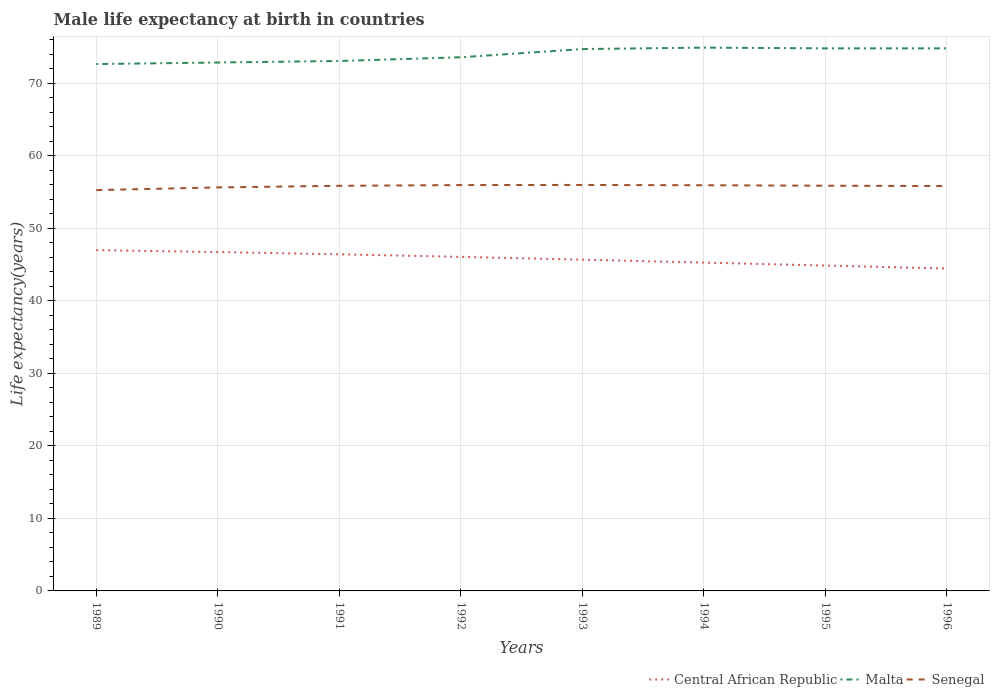Does the line corresponding to Malta intersect with the line corresponding to Senegal?
Your answer should be very brief. No. Across all years, what is the maximum male life expectancy at birth in Malta?
Your response must be concise. 72.63. What is the total male life expectancy at birth in Central African Republic in the graph?
Keep it short and to the point. 0.31. What is the difference between the highest and the second highest male life expectancy at birth in Malta?
Offer a terse response. 2.27. Is the male life expectancy at birth in Central African Republic strictly greater than the male life expectancy at birth in Senegal over the years?
Provide a succinct answer. Yes. How many years are there in the graph?
Ensure brevity in your answer.  8. What is the difference between two consecutive major ticks on the Y-axis?
Your answer should be very brief. 10. Are the values on the major ticks of Y-axis written in scientific E-notation?
Your response must be concise. No. Does the graph contain any zero values?
Ensure brevity in your answer.  No. How many legend labels are there?
Your answer should be compact. 3. How are the legend labels stacked?
Give a very brief answer. Horizontal. What is the title of the graph?
Ensure brevity in your answer.  Male life expectancy at birth in countries. What is the label or title of the X-axis?
Your answer should be compact. Years. What is the label or title of the Y-axis?
Your response must be concise. Life expectancy(years). What is the Life expectancy(years) in Central African Republic in 1989?
Make the answer very short. 46.98. What is the Life expectancy(years) of Malta in 1989?
Your response must be concise. 72.63. What is the Life expectancy(years) in Senegal in 1989?
Provide a succinct answer. 55.26. What is the Life expectancy(years) of Central African Republic in 1990?
Provide a short and direct response. 46.72. What is the Life expectancy(years) of Malta in 1990?
Ensure brevity in your answer.  72.85. What is the Life expectancy(years) of Senegal in 1990?
Keep it short and to the point. 55.63. What is the Life expectancy(years) in Central African Republic in 1991?
Your response must be concise. 46.41. What is the Life expectancy(years) in Malta in 1991?
Provide a short and direct response. 73.06. What is the Life expectancy(years) of Senegal in 1991?
Give a very brief answer. 55.85. What is the Life expectancy(years) of Central African Republic in 1992?
Your answer should be very brief. 46.05. What is the Life expectancy(years) in Malta in 1992?
Keep it short and to the point. 73.57. What is the Life expectancy(years) of Senegal in 1992?
Your response must be concise. 55.95. What is the Life expectancy(years) of Central African Republic in 1993?
Give a very brief answer. 45.67. What is the Life expectancy(years) in Malta in 1993?
Provide a short and direct response. 74.7. What is the Life expectancy(years) of Senegal in 1993?
Provide a short and direct response. 55.97. What is the Life expectancy(years) of Central African Republic in 1994?
Ensure brevity in your answer.  45.27. What is the Life expectancy(years) in Malta in 1994?
Ensure brevity in your answer.  74.9. What is the Life expectancy(years) in Senegal in 1994?
Give a very brief answer. 55.93. What is the Life expectancy(years) of Central African Republic in 1995?
Your answer should be very brief. 44.86. What is the Life expectancy(years) of Malta in 1995?
Give a very brief answer. 74.8. What is the Life expectancy(years) in Senegal in 1995?
Provide a succinct answer. 55.86. What is the Life expectancy(years) in Central African Republic in 1996?
Offer a very short reply. 44.45. What is the Life expectancy(years) of Malta in 1996?
Offer a terse response. 74.8. What is the Life expectancy(years) of Senegal in 1996?
Offer a terse response. 55.81. Across all years, what is the maximum Life expectancy(years) of Central African Republic?
Give a very brief answer. 46.98. Across all years, what is the maximum Life expectancy(years) of Malta?
Provide a succinct answer. 74.9. Across all years, what is the maximum Life expectancy(years) of Senegal?
Make the answer very short. 55.97. Across all years, what is the minimum Life expectancy(years) in Central African Republic?
Make the answer very short. 44.45. Across all years, what is the minimum Life expectancy(years) in Malta?
Offer a terse response. 72.63. Across all years, what is the minimum Life expectancy(years) in Senegal?
Your answer should be very brief. 55.26. What is the total Life expectancy(years) of Central African Republic in the graph?
Your response must be concise. 366.4. What is the total Life expectancy(years) in Malta in the graph?
Offer a terse response. 591.31. What is the total Life expectancy(years) of Senegal in the graph?
Provide a short and direct response. 446.25. What is the difference between the Life expectancy(years) in Central African Republic in 1989 and that in 1990?
Your answer should be compact. 0.26. What is the difference between the Life expectancy(years) of Malta in 1989 and that in 1990?
Provide a short and direct response. -0.21. What is the difference between the Life expectancy(years) in Senegal in 1989 and that in 1990?
Offer a very short reply. -0.37. What is the difference between the Life expectancy(years) of Central African Republic in 1989 and that in 1991?
Ensure brevity in your answer.  0.58. What is the difference between the Life expectancy(years) of Malta in 1989 and that in 1991?
Offer a very short reply. -0.42. What is the difference between the Life expectancy(years) in Senegal in 1989 and that in 1991?
Your response must be concise. -0.59. What is the difference between the Life expectancy(years) in Central African Republic in 1989 and that in 1992?
Your response must be concise. 0.93. What is the difference between the Life expectancy(years) in Malta in 1989 and that in 1992?
Provide a succinct answer. -0.94. What is the difference between the Life expectancy(years) of Senegal in 1989 and that in 1992?
Ensure brevity in your answer.  -0.69. What is the difference between the Life expectancy(years) in Central African Republic in 1989 and that in 1993?
Your response must be concise. 1.32. What is the difference between the Life expectancy(years) of Malta in 1989 and that in 1993?
Keep it short and to the point. -2.07. What is the difference between the Life expectancy(years) of Senegal in 1989 and that in 1993?
Make the answer very short. -0.71. What is the difference between the Life expectancy(years) of Central African Republic in 1989 and that in 1994?
Your answer should be very brief. 1.72. What is the difference between the Life expectancy(years) in Malta in 1989 and that in 1994?
Provide a succinct answer. -2.27. What is the difference between the Life expectancy(years) in Senegal in 1989 and that in 1994?
Keep it short and to the point. -0.67. What is the difference between the Life expectancy(years) in Central African Republic in 1989 and that in 1995?
Keep it short and to the point. 2.13. What is the difference between the Life expectancy(years) of Malta in 1989 and that in 1995?
Keep it short and to the point. -2.17. What is the difference between the Life expectancy(years) of Senegal in 1989 and that in 1995?
Your response must be concise. -0.61. What is the difference between the Life expectancy(years) of Central African Republic in 1989 and that in 1996?
Ensure brevity in your answer.  2.54. What is the difference between the Life expectancy(years) of Malta in 1989 and that in 1996?
Offer a very short reply. -2.17. What is the difference between the Life expectancy(years) of Senegal in 1989 and that in 1996?
Offer a very short reply. -0.56. What is the difference between the Life expectancy(years) of Central African Republic in 1990 and that in 1991?
Your response must be concise. 0.31. What is the difference between the Life expectancy(years) of Malta in 1990 and that in 1991?
Your response must be concise. -0.21. What is the difference between the Life expectancy(years) of Senegal in 1990 and that in 1991?
Your answer should be very brief. -0.22. What is the difference between the Life expectancy(years) of Central African Republic in 1990 and that in 1992?
Make the answer very short. 0.67. What is the difference between the Life expectancy(years) of Malta in 1990 and that in 1992?
Give a very brief answer. -0.72. What is the difference between the Life expectancy(years) in Senegal in 1990 and that in 1992?
Your response must be concise. -0.32. What is the difference between the Life expectancy(years) of Central African Republic in 1990 and that in 1993?
Provide a succinct answer. 1.05. What is the difference between the Life expectancy(years) of Malta in 1990 and that in 1993?
Your response must be concise. -1.85. What is the difference between the Life expectancy(years) in Senegal in 1990 and that in 1993?
Make the answer very short. -0.34. What is the difference between the Life expectancy(years) of Central African Republic in 1990 and that in 1994?
Make the answer very short. 1.46. What is the difference between the Life expectancy(years) in Malta in 1990 and that in 1994?
Make the answer very short. -2.05. What is the difference between the Life expectancy(years) in Senegal in 1990 and that in 1994?
Make the answer very short. -0.3. What is the difference between the Life expectancy(years) of Central African Republic in 1990 and that in 1995?
Your response must be concise. 1.86. What is the difference between the Life expectancy(years) in Malta in 1990 and that in 1995?
Keep it short and to the point. -1.95. What is the difference between the Life expectancy(years) of Senegal in 1990 and that in 1995?
Offer a terse response. -0.24. What is the difference between the Life expectancy(years) of Central African Republic in 1990 and that in 1996?
Offer a very short reply. 2.27. What is the difference between the Life expectancy(years) in Malta in 1990 and that in 1996?
Your response must be concise. -1.95. What is the difference between the Life expectancy(years) of Senegal in 1990 and that in 1996?
Provide a succinct answer. -0.19. What is the difference between the Life expectancy(years) in Central African Republic in 1991 and that in 1992?
Give a very brief answer. 0.35. What is the difference between the Life expectancy(years) of Malta in 1991 and that in 1992?
Your answer should be compact. -0.51. What is the difference between the Life expectancy(years) in Senegal in 1991 and that in 1992?
Ensure brevity in your answer.  -0.1. What is the difference between the Life expectancy(years) in Central African Republic in 1991 and that in 1993?
Provide a succinct answer. 0.74. What is the difference between the Life expectancy(years) of Malta in 1991 and that in 1993?
Make the answer very short. -1.64. What is the difference between the Life expectancy(years) of Senegal in 1991 and that in 1993?
Make the answer very short. -0.12. What is the difference between the Life expectancy(years) in Central African Republic in 1991 and that in 1994?
Provide a succinct answer. 1.14. What is the difference between the Life expectancy(years) in Malta in 1991 and that in 1994?
Your answer should be compact. -1.84. What is the difference between the Life expectancy(years) in Senegal in 1991 and that in 1994?
Give a very brief answer. -0.08. What is the difference between the Life expectancy(years) in Central African Republic in 1991 and that in 1995?
Ensure brevity in your answer.  1.55. What is the difference between the Life expectancy(years) in Malta in 1991 and that in 1995?
Offer a terse response. -1.74. What is the difference between the Life expectancy(years) of Senegal in 1991 and that in 1995?
Your answer should be very brief. -0.01. What is the difference between the Life expectancy(years) in Central African Republic in 1991 and that in 1996?
Provide a short and direct response. 1.96. What is the difference between the Life expectancy(years) in Malta in 1991 and that in 1996?
Provide a short and direct response. -1.74. What is the difference between the Life expectancy(years) in Senegal in 1991 and that in 1996?
Ensure brevity in your answer.  0.04. What is the difference between the Life expectancy(years) of Central African Republic in 1992 and that in 1993?
Offer a very short reply. 0.39. What is the difference between the Life expectancy(years) of Malta in 1992 and that in 1993?
Provide a succinct answer. -1.13. What is the difference between the Life expectancy(years) in Senegal in 1992 and that in 1993?
Your answer should be compact. -0.01. What is the difference between the Life expectancy(years) of Central African Republic in 1992 and that in 1994?
Keep it short and to the point. 0.79. What is the difference between the Life expectancy(years) in Malta in 1992 and that in 1994?
Ensure brevity in your answer.  -1.33. What is the difference between the Life expectancy(years) of Senegal in 1992 and that in 1994?
Your answer should be compact. 0.03. What is the difference between the Life expectancy(years) of Central African Republic in 1992 and that in 1995?
Your answer should be very brief. 1.2. What is the difference between the Life expectancy(years) of Malta in 1992 and that in 1995?
Make the answer very short. -1.23. What is the difference between the Life expectancy(years) in Senegal in 1992 and that in 1995?
Provide a short and direct response. 0.09. What is the difference between the Life expectancy(years) in Central African Republic in 1992 and that in 1996?
Give a very brief answer. 1.61. What is the difference between the Life expectancy(years) of Malta in 1992 and that in 1996?
Your answer should be compact. -1.23. What is the difference between the Life expectancy(years) in Senegal in 1992 and that in 1996?
Your answer should be very brief. 0.14. What is the difference between the Life expectancy(years) in Central African Republic in 1993 and that in 1994?
Your answer should be compact. 0.4. What is the difference between the Life expectancy(years) in Central African Republic in 1993 and that in 1995?
Offer a terse response. 0.81. What is the difference between the Life expectancy(years) in Senegal in 1993 and that in 1995?
Make the answer very short. 0.1. What is the difference between the Life expectancy(years) in Central African Republic in 1993 and that in 1996?
Provide a short and direct response. 1.22. What is the difference between the Life expectancy(years) of Senegal in 1993 and that in 1996?
Your answer should be very brief. 0.15. What is the difference between the Life expectancy(years) of Central African Republic in 1994 and that in 1995?
Offer a very short reply. 0.41. What is the difference between the Life expectancy(years) of Malta in 1994 and that in 1995?
Provide a succinct answer. 0.1. What is the difference between the Life expectancy(years) of Senegal in 1994 and that in 1995?
Offer a terse response. 0.06. What is the difference between the Life expectancy(years) of Central African Republic in 1994 and that in 1996?
Give a very brief answer. 0.82. What is the difference between the Life expectancy(years) in Senegal in 1994 and that in 1996?
Offer a very short reply. 0.11. What is the difference between the Life expectancy(years) in Central African Republic in 1995 and that in 1996?
Ensure brevity in your answer.  0.41. What is the difference between the Life expectancy(years) in Senegal in 1995 and that in 1996?
Your answer should be very brief. 0.05. What is the difference between the Life expectancy(years) of Central African Republic in 1989 and the Life expectancy(years) of Malta in 1990?
Provide a short and direct response. -25.86. What is the difference between the Life expectancy(years) in Central African Republic in 1989 and the Life expectancy(years) in Senegal in 1990?
Offer a very short reply. -8.64. What is the difference between the Life expectancy(years) in Malta in 1989 and the Life expectancy(years) in Senegal in 1990?
Provide a succinct answer. 17.01. What is the difference between the Life expectancy(years) in Central African Republic in 1989 and the Life expectancy(years) in Malta in 1991?
Give a very brief answer. -26.07. What is the difference between the Life expectancy(years) in Central African Republic in 1989 and the Life expectancy(years) in Senegal in 1991?
Your response must be concise. -8.87. What is the difference between the Life expectancy(years) of Malta in 1989 and the Life expectancy(years) of Senegal in 1991?
Offer a terse response. 16.79. What is the difference between the Life expectancy(years) of Central African Republic in 1989 and the Life expectancy(years) of Malta in 1992?
Provide a succinct answer. -26.59. What is the difference between the Life expectancy(years) of Central African Republic in 1989 and the Life expectancy(years) of Senegal in 1992?
Your response must be concise. -8.97. What is the difference between the Life expectancy(years) of Malta in 1989 and the Life expectancy(years) of Senegal in 1992?
Provide a short and direct response. 16.68. What is the difference between the Life expectancy(years) in Central African Republic in 1989 and the Life expectancy(years) in Malta in 1993?
Ensure brevity in your answer.  -27.72. What is the difference between the Life expectancy(years) of Central African Republic in 1989 and the Life expectancy(years) of Senegal in 1993?
Make the answer very short. -8.98. What is the difference between the Life expectancy(years) in Malta in 1989 and the Life expectancy(years) in Senegal in 1993?
Offer a very short reply. 16.67. What is the difference between the Life expectancy(years) in Central African Republic in 1989 and the Life expectancy(years) in Malta in 1994?
Your answer should be very brief. -27.92. What is the difference between the Life expectancy(years) in Central African Republic in 1989 and the Life expectancy(years) in Senegal in 1994?
Provide a short and direct response. -8.94. What is the difference between the Life expectancy(years) of Malta in 1989 and the Life expectancy(years) of Senegal in 1994?
Give a very brief answer. 16.71. What is the difference between the Life expectancy(years) of Central African Republic in 1989 and the Life expectancy(years) of Malta in 1995?
Your answer should be compact. -27.82. What is the difference between the Life expectancy(years) of Central African Republic in 1989 and the Life expectancy(years) of Senegal in 1995?
Offer a very short reply. -8.88. What is the difference between the Life expectancy(years) in Malta in 1989 and the Life expectancy(years) in Senegal in 1995?
Offer a very short reply. 16.77. What is the difference between the Life expectancy(years) of Central African Republic in 1989 and the Life expectancy(years) of Malta in 1996?
Give a very brief answer. -27.82. What is the difference between the Life expectancy(years) in Central African Republic in 1989 and the Life expectancy(years) in Senegal in 1996?
Make the answer very short. -8.83. What is the difference between the Life expectancy(years) of Malta in 1989 and the Life expectancy(years) of Senegal in 1996?
Ensure brevity in your answer.  16.82. What is the difference between the Life expectancy(years) in Central African Republic in 1990 and the Life expectancy(years) in Malta in 1991?
Ensure brevity in your answer.  -26.34. What is the difference between the Life expectancy(years) of Central African Republic in 1990 and the Life expectancy(years) of Senegal in 1991?
Provide a short and direct response. -9.13. What is the difference between the Life expectancy(years) in Malta in 1990 and the Life expectancy(years) in Senegal in 1991?
Provide a succinct answer. 17. What is the difference between the Life expectancy(years) in Central African Republic in 1990 and the Life expectancy(years) in Malta in 1992?
Offer a terse response. -26.85. What is the difference between the Life expectancy(years) in Central African Republic in 1990 and the Life expectancy(years) in Senegal in 1992?
Your response must be concise. -9.23. What is the difference between the Life expectancy(years) of Malta in 1990 and the Life expectancy(years) of Senegal in 1992?
Make the answer very short. 16.9. What is the difference between the Life expectancy(years) of Central African Republic in 1990 and the Life expectancy(years) of Malta in 1993?
Make the answer very short. -27.98. What is the difference between the Life expectancy(years) in Central African Republic in 1990 and the Life expectancy(years) in Senegal in 1993?
Your answer should be compact. -9.25. What is the difference between the Life expectancy(years) of Malta in 1990 and the Life expectancy(years) of Senegal in 1993?
Your answer should be very brief. 16.88. What is the difference between the Life expectancy(years) in Central African Republic in 1990 and the Life expectancy(years) in Malta in 1994?
Your answer should be very brief. -28.18. What is the difference between the Life expectancy(years) in Central African Republic in 1990 and the Life expectancy(years) in Senegal in 1994?
Provide a short and direct response. -9.21. What is the difference between the Life expectancy(years) of Malta in 1990 and the Life expectancy(years) of Senegal in 1994?
Give a very brief answer. 16.92. What is the difference between the Life expectancy(years) in Central African Republic in 1990 and the Life expectancy(years) in Malta in 1995?
Your answer should be compact. -28.08. What is the difference between the Life expectancy(years) of Central African Republic in 1990 and the Life expectancy(years) of Senegal in 1995?
Give a very brief answer. -9.14. What is the difference between the Life expectancy(years) in Malta in 1990 and the Life expectancy(years) in Senegal in 1995?
Your answer should be very brief. 16.98. What is the difference between the Life expectancy(years) of Central African Republic in 1990 and the Life expectancy(years) of Malta in 1996?
Offer a terse response. -28.08. What is the difference between the Life expectancy(years) in Central African Republic in 1990 and the Life expectancy(years) in Senegal in 1996?
Your answer should be very brief. -9.09. What is the difference between the Life expectancy(years) in Malta in 1990 and the Life expectancy(years) in Senegal in 1996?
Your answer should be compact. 17.03. What is the difference between the Life expectancy(years) in Central African Republic in 1991 and the Life expectancy(years) in Malta in 1992?
Provide a succinct answer. -27.16. What is the difference between the Life expectancy(years) of Central African Republic in 1991 and the Life expectancy(years) of Senegal in 1992?
Give a very brief answer. -9.54. What is the difference between the Life expectancy(years) of Malta in 1991 and the Life expectancy(years) of Senegal in 1992?
Provide a short and direct response. 17.11. What is the difference between the Life expectancy(years) of Central African Republic in 1991 and the Life expectancy(years) of Malta in 1993?
Make the answer very short. -28.29. What is the difference between the Life expectancy(years) in Central African Republic in 1991 and the Life expectancy(years) in Senegal in 1993?
Your answer should be very brief. -9.56. What is the difference between the Life expectancy(years) of Malta in 1991 and the Life expectancy(years) of Senegal in 1993?
Make the answer very short. 17.09. What is the difference between the Life expectancy(years) in Central African Republic in 1991 and the Life expectancy(years) in Malta in 1994?
Provide a succinct answer. -28.49. What is the difference between the Life expectancy(years) in Central African Republic in 1991 and the Life expectancy(years) in Senegal in 1994?
Your response must be concise. -9.52. What is the difference between the Life expectancy(years) in Malta in 1991 and the Life expectancy(years) in Senegal in 1994?
Offer a very short reply. 17.13. What is the difference between the Life expectancy(years) in Central African Republic in 1991 and the Life expectancy(years) in Malta in 1995?
Provide a succinct answer. -28.39. What is the difference between the Life expectancy(years) in Central African Republic in 1991 and the Life expectancy(years) in Senegal in 1995?
Your answer should be very brief. -9.46. What is the difference between the Life expectancy(years) of Malta in 1991 and the Life expectancy(years) of Senegal in 1995?
Keep it short and to the point. 17.19. What is the difference between the Life expectancy(years) in Central African Republic in 1991 and the Life expectancy(years) in Malta in 1996?
Your answer should be very brief. -28.39. What is the difference between the Life expectancy(years) of Central African Republic in 1991 and the Life expectancy(years) of Senegal in 1996?
Your answer should be very brief. -9.41. What is the difference between the Life expectancy(years) in Malta in 1991 and the Life expectancy(years) in Senegal in 1996?
Keep it short and to the point. 17.25. What is the difference between the Life expectancy(years) in Central African Republic in 1992 and the Life expectancy(years) in Malta in 1993?
Your answer should be compact. -28.65. What is the difference between the Life expectancy(years) of Central African Republic in 1992 and the Life expectancy(years) of Senegal in 1993?
Your response must be concise. -9.91. What is the difference between the Life expectancy(years) of Malta in 1992 and the Life expectancy(years) of Senegal in 1993?
Provide a short and direct response. 17.6. What is the difference between the Life expectancy(years) in Central African Republic in 1992 and the Life expectancy(years) in Malta in 1994?
Give a very brief answer. -28.85. What is the difference between the Life expectancy(years) of Central African Republic in 1992 and the Life expectancy(years) of Senegal in 1994?
Your answer should be very brief. -9.87. What is the difference between the Life expectancy(years) of Malta in 1992 and the Life expectancy(years) of Senegal in 1994?
Your response must be concise. 17.64. What is the difference between the Life expectancy(years) in Central African Republic in 1992 and the Life expectancy(years) in Malta in 1995?
Ensure brevity in your answer.  -28.75. What is the difference between the Life expectancy(years) in Central African Republic in 1992 and the Life expectancy(years) in Senegal in 1995?
Provide a succinct answer. -9.81. What is the difference between the Life expectancy(years) of Malta in 1992 and the Life expectancy(years) of Senegal in 1995?
Keep it short and to the point. 17.71. What is the difference between the Life expectancy(years) in Central African Republic in 1992 and the Life expectancy(years) in Malta in 1996?
Your answer should be compact. -28.75. What is the difference between the Life expectancy(years) in Central African Republic in 1992 and the Life expectancy(years) in Senegal in 1996?
Keep it short and to the point. -9.76. What is the difference between the Life expectancy(years) in Malta in 1992 and the Life expectancy(years) in Senegal in 1996?
Your answer should be compact. 17.76. What is the difference between the Life expectancy(years) in Central African Republic in 1993 and the Life expectancy(years) in Malta in 1994?
Make the answer very short. -29.23. What is the difference between the Life expectancy(years) in Central African Republic in 1993 and the Life expectancy(years) in Senegal in 1994?
Give a very brief answer. -10.26. What is the difference between the Life expectancy(years) in Malta in 1993 and the Life expectancy(years) in Senegal in 1994?
Make the answer very short. 18.77. What is the difference between the Life expectancy(years) in Central African Republic in 1993 and the Life expectancy(years) in Malta in 1995?
Make the answer very short. -29.13. What is the difference between the Life expectancy(years) in Central African Republic in 1993 and the Life expectancy(years) in Senegal in 1995?
Make the answer very short. -10.2. What is the difference between the Life expectancy(years) of Malta in 1993 and the Life expectancy(years) of Senegal in 1995?
Ensure brevity in your answer.  18.84. What is the difference between the Life expectancy(years) of Central African Republic in 1993 and the Life expectancy(years) of Malta in 1996?
Provide a short and direct response. -29.13. What is the difference between the Life expectancy(years) of Central African Republic in 1993 and the Life expectancy(years) of Senegal in 1996?
Offer a very short reply. -10.15. What is the difference between the Life expectancy(years) in Malta in 1993 and the Life expectancy(years) in Senegal in 1996?
Provide a short and direct response. 18.89. What is the difference between the Life expectancy(years) of Central African Republic in 1994 and the Life expectancy(years) of Malta in 1995?
Your answer should be very brief. -29.54. What is the difference between the Life expectancy(years) of Central African Republic in 1994 and the Life expectancy(years) of Senegal in 1995?
Keep it short and to the point. -10.6. What is the difference between the Life expectancy(years) in Malta in 1994 and the Life expectancy(years) in Senegal in 1995?
Your response must be concise. 19.04. What is the difference between the Life expectancy(years) of Central African Republic in 1994 and the Life expectancy(years) of Malta in 1996?
Make the answer very short. -29.54. What is the difference between the Life expectancy(years) in Central African Republic in 1994 and the Life expectancy(years) in Senegal in 1996?
Your response must be concise. -10.55. What is the difference between the Life expectancy(years) of Malta in 1994 and the Life expectancy(years) of Senegal in 1996?
Provide a succinct answer. 19.09. What is the difference between the Life expectancy(years) in Central African Republic in 1995 and the Life expectancy(years) in Malta in 1996?
Keep it short and to the point. -29.94. What is the difference between the Life expectancy(years) of Central African Republic in 1995 and the Life expectancy(years) of Senegal in 1996?
Give a very brief answer. -10.96. What is the difference between the Life expectancy(years) of Malta in 1995 and the Life expectancy(years) of Senegal in 1996?
Your answer should be very brief. 18.99. What is the average Life expectancy(years) in Central African Republic per year?
Ensure brevity in your answer.  45.8. What is the average Life expectancy(years) in Malta per year?
Keep it short and to the point. 73.91. What is the average Life expectancy(years) of Senegal per year?
Keep it short and to the point. 55.78. In the year 1989, what is the difference between the Life expectancy(years) of Central African Republic and Life expectancy(years) of Malta?
Your answer should be compact. -25.65. In the year 1989, what is the difference between the Life expectancy(years) of Central African Republic and Life expectancy(years) of Senegal?
Provide a short and direct response. -8.27. In the year 1989, what is the difference between the Life expectancy(years) in Malta and Life expectancy(years) in Senegal?
Your answer should be very brief. 17.38. In the year 1990, what is the difference between the Life expectancy(years) in Central African Republic and Life expectancy(years) in Malta?
Give a very brief answer. -26.13. In the year 1990, what is the difference between the Life expectancy(years) in Central African Republic and Life expectancy(years) in Senegal?
Offer a terse response. -8.91. In the year 1990, what is the difference between the Life expectancy(years) of Malta and Life expectancy(years) of Senegal?
Your answer should be very brief. 17.22. In the year 1991, what is the difference between the Life expectancy(years) of Central African Republic and Life expectancy(years) of Malta?
Give a very brief answer. -26.65. In the year 1991, what is the difference between the Life expectancy(years) of Central African Republic and Life expectancy(years) of Senegal?
Offer a terse response. -9.44. In the year 1991, what is the difference between the Life expectancy(years) in Malta and Life expectancy(years) in Senegal?
Make the answer very short. 17.21. In the year 1992, what is the difference between the Life expectancy(years) of Central African Republic and Life expectancy(years) of Malta?
Offer a terse response. -27.52. In the year 1992, what is the difference between the Life expectancy(years) in Central African Republic and Life expectancy(years) in Senegal?
Make the answer very short. -9.9. In the year 1992, what is the difference between the Life expectancy(years) in Malta and Life expectancy(years) in Senegal?
Provide a short and direct response. 17.62. In the year 1993, what is the difference between the Life expectancy(years) of Central African Republic and Life expectancy(years) of Malta?
Ensure brevity in your answer.  -29.03. In the year 1993, what is the difference between the Life expectancy(years) of Central African Republic and Life expectancy(years) of Senegal?
Provide a short and direct response. -10.3. In the year 1993, what is the difference between the Life expectancy(years) in Malta and Life expectancy(years) in Senegal?
Give a very brief answer. 18.73. In the year 1994, what is the difference between the Life expectancy(years) in Central African Republic and Life expectancy(years) in Malta?
Your answer should be very brief. -29.64. In the year 1994, what is the difference between the Life expectancy(years) in Central African Republic and Life expectancy(years) in Senegal?
Give a very brief answer. -10.66. In the year 1994, what is the difference between the Life expectancy(years) in Malta and Life expectancy(years) in Senegal?
Your response must be concise. 18.97. In the year 1995, what is the difference between the Life expectancy(years) in Central African Republic and Life expectancy(years) in Malta?
Make the answer very short. -29.94. In the year 1995, what is the difference between the Life expectancy(years) in Central African Republic and Life expectancy(years) in Senegal?
Offer a very short reply. -11.01. In the year 1995, what is the difference between the Life expectancy(years) of Malta and Life expectancy(years) of Senegal?
Provide a short and direct response. 18.94. In the year 1996, what is the difference between the Life expectancy(years) in Central African Republic and Life expectancy(years) in Malta?
Make the answer very short. -30.36. In the year 1996, what is the difference between the Life expectancy(years) in Central African Republic and Life expectancy(years) in Senegal?
Provide a succinct answer. -11.37. In the year 1996, what is the difference between the Life expectancy(years) in Malta and Life expectancy(years) in Senegal?
Offer a terse response. 18.99. What is the ratio of the Life expectancy(years) of Malta in 1989 to that in 1990?
Your answer should be compact. 1. What is the ratio of the Life expectancy(years) in Central African Republic in 1989 to that in 1991?
Give a very brief answer. 1.01. What is the ratio of the Life expectancy(years) of Senegal in 1989 to that in 1991?
Ensure brevity in your answer.  0.99. What is the ratio of the Life expectancy(years) in Central African Republic in 1989 to that in 1992?
Your answer should be very brief. 1.02. What is the ratio of the Life expectancy(years) of Malta in 1989 to that in 1992?
Your answer should be very brief. 0.99. What is the ratio of the Life expectancy(years) in Senegal in 1989 to that in 1992?
Give a very brief answer. 0.99. What is the ratio of the Life expectancy(years) of Central African Republic in 1989 to that in 1993?
Make the answer very short. 1.03. What is the ratio of the Life expectancy(years) of Malta in 1989 to that in 1993?
Provide a succinct answer. 0.97. What is the ratio of the Life expectancy(years) of Senegal in 1989 to that in 1993?
Give a very brief answer. 0.99. What is the ratio of the Life expectancy(years) of Central African Republic in 1989 to that in 1994?
Your response must be concise. 1.04. What is the ratio of the Life expectancy(years) of Malta in 1989 to that in 1994?
Give a very brief answer. 0.97. What is the ratio of the Life expectancy(years) in Senegal in 1989 to that in 1994?
Give a very brief answer. 0.99. What is the ratio of the Life expectancy(years) in Central African Republic in 1989 to that in 1995?
Offer a very short reply. 1.05. What is the ratio of the Life expectancy(years) in Senegal in 1989 to that in 1995?
Your response must be concise. 0.99. What is the ratio of the Life expectancy(years) of Central African Republic in 1989 to that in 1996?
Make the answer very short. 1.06. What is the ratio of the Life expectancy(years) in Malta in 1989 to that in 1996?
Offer a terse response. 0.97. What is the ratio of the Life expectancy(years) in Senegal in 1989 to that in 1996?
Your response must be concise. 0.99. What is the ratio of the Life expectancy(years) in Malta in 1990 to that in 1991?
Your answer should be very brief. 1. What is the ratio of the Life expectancy(years) in Central African Republic in 1990 to that in 1992?
Give a very brief answer. 1.01. What is the ratio of the Life expectancy(years) of Malta in 1990 to that in 1992?
Keep it short and to the point. 0.99. What is the ratio of the Life expectancy(years) in Senegal in 1990 to that in 1992?
Offer a very short reply. 0.99. What is the ratio of the Life expectancy(years) of Central African Republic in 1990 to that in 1993?
Offer a terse response. 1.02. What is the ratio of the Life expectancy(years) of Malta in 1990 to that in 1993?
Offer a terse response. 0.98. What is the ratio of the Life expectancy(years) in Senegal in 1990 to that in 1993?
Offer a terse response. 0.99. What is the ratio of the Life expectancy(years) of Central African Republic in 1990 to that in 1994?
Your answer should be compact. 1.03. What is the ratio of the Life expectancy(years) in Malta in 1990 to that in 1994?
Keep it short and to the point. 0.97. What is the ratio of the Life expectancy(years) in Central African Republic in 1990 to that in 1995?
Provide a succinct answer. 1.04. What is the ratio of the Life expectancy(years) of Malta in 1990 to that in 1995?
Your answer should be compact. 0.97. What is the ratio of the Life expectancy(years) of Senegal in 1990 to that in 1995?
Ensure brevity in your answer.  1. What is the ratio of the Life expectancy(years) in Central African Republic in 1990 to that in 1996?
Make the answer very short. 1.05. What is the ratio of the Life expectancy(years) in Malta in 1990 to that in 1996?
Offer a terse response. 0.97. What is the ratio of the Life expectancy(years) in Central African Republic in 1991 to that in 1992?
Offer a terse response. 1.01. What is the ratio of the Life expectancy(years) in Malta in 1991 to that in 1992?
Ensure brevity in your answer.  0.99. What is the ratio of the Life expectancy(years) of Central African Republic in 1991 to that in 1993?
Make the answer very short. 1.02. What is the ratio of the Life expectancy(years) of Senegal in 1991 to that in 1993?
Offer a terse response. 1. What is the ratio of the Life expectancy(years) in Central African Republic in 1991 to that in 1994?
Offer a very short reply. 1.03. What is the ratio of the Life expectancy(years) in Malta in 1991 to that in 1994?
Ensure brevity in your answer.  0.98. What is the ratio of the Life expectancy(years) in Senegal in 1991 to that in 1994?
Your response must be concise. 1. What is the ratio of the Life expectancy(years) of Central African Republic in 1991 to that in 1995?
Your answer should be compact. 1.03. What is the ratio of the Life expectancy(years) in Malta in 1991 to that in 1995?
Your response must be concise. 0.98. What is the ratio of the Life expectancy(years) of Senegal in 1991 to that in 1995?
Your answer should be very brief. 1. What is the ratio of the Life expectancy(years) in Central African Republic in 1991 to that in 1996?
Keep it short and to the point. 1.04. What is the ratio of the Life expectancy(years) in Malta in 1991 to that in 1996?
Provide a short and direct response. 0.98. What is the ratio of the Life expectancy(years) in Senegal in 1991 to that in 1996?
Provide a short and direct response. 1. What is the ratio of the Life expectancy(years) of Central African Republic in 1992 to that in 1993?
Provide a short and direct response. 1.01. What is the ratio of the Life expectancy(years) in Malta in 1992 to that in 1993?
Offer a very short reply. 0.98. What is the ratio of the Life expectancy(years) of Central African Republic in 1992 to that in 1994?
Make the answer very short. 1.02. What is the ratio of the Life expectancy(years) of Malta in 1992 to that in 1994?
Ensure brevity in your answer.  0.98. What is the ratio of the Life expectancy(years) in Senegal in 1992 to that in 1994?
Ensure brevity in your answer.  1. What is the ratio of the Life expectancy(years) of Central African Republic in 1992 to that in 1995?
Give a very brief answer. 1.03. What is the ratio of the Life expectancy(years) of Malta in 1992 to that in 1995?
Keep it short and to the point. 0.98. What is the ratio of the Life expectancy(years) of Senegal in 1992 to that in 1995?
Your response must be concise. 1. What is the ratio of the Life expectancy(years) of Central African Republic in 1992 to that in 1996?
Keep it short and to the point. 1.04. What is the ratio of the Life expectancy(years) in Malta in 1992 to that in 1996?
Make the answer very short. 0.98. What is the ratio of the Life expectancy(years) in Senegal in 1992 to that in 1996?
Your response must be concise. 1. What is the ratio of the Life expectancy(years) in Central African Republic in 1993 to that in 1994?
Provide a short and direct response. 1.01. What is the ratio of the Life expectancy(years) of Malta in 1993 to that in 1994?
Offer a terse response. 1. What is the ratio of the Life expectancy(years) of Senegal in 1993 to that in 1994?
Make the answer very short. 1. What is the ratio of the Life expectancy(years) of Central African Republic in 1993 to that in 1995?
Your response must be concise. 1.02. What is the ratio of the Life expectancy(years) of Central African Republic in 1993 to that in 1996?
Give a very brief answer. 1.03. What is the ratio of the Life expectancy(years) in Senegal in 1993 to that in 1996?
Your answer should be very brief. 1. What is the ratio of the Life expectancy(years) in Central African Republic in 1994 to that in 1995?
Your answer should be very brief. 1.01. What is the ratio of the Life expectancy(years) of Malta in 1994 to that in 1995?
Provide a short and direct response. 1. What is the ratio of the Life expectancy(years) in Senegal in 1994 to that in 1995?
Keep it short and to the point. 1. What is the ratio of the Life expectancy(years) of Central African Republic in 1994 to that in 1996?
Your response must be concise. 1.02. What is the ratio of the Life expectancy(years) in Senegal in 1994 to that in 1996?
Offer a very short reply. 1. What is the ratio of the Life expectancy(years) in Central African Republic in 1995 to that in 1996?
Make the answer very short. 1.01. What is the difference between the highest and the second highest Life expectancy(years) in Central African Republic?
Your response must be concise. 0.26. What is the difference between the highest and the second highest Life expectancy(years) in Malta?
Keep it short and to the point. 0.1. What is the difference between the highest and the second highest Life expectancy(years) in Senegal?
Your answer should be very brief. 0.01. What is the difference between the highest and the lowest Life expectancy(years) of Central African Republic?
Ensure brevity in your answer.  2.54. What is the difference between the highest and the lowest Life expectancy(years) of Malta?
Ensure brevity in your answer.  2.27. What is the difference between the highest and the lowest Life expectancy(years) of Senegal?
Your answer should be very brief. 0.71. 